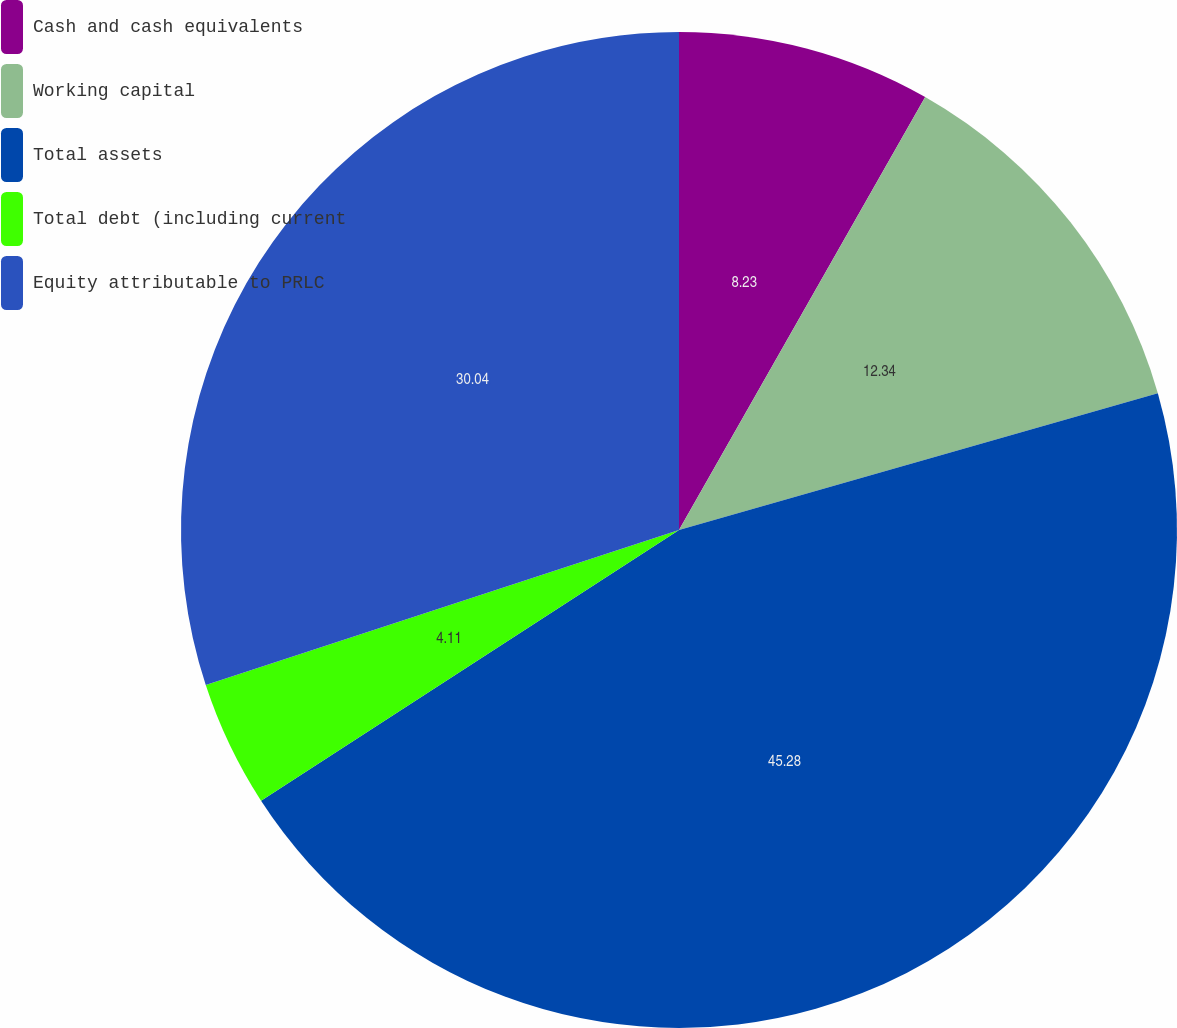<chart> <loc_0><loc_0><loc_500><loc_500><pie_chart><fcel>Cash and cash equivalents<fcel>Working capital<fcel>Total assets<fcel>Total debt (including current<fcel>Equity attributable to PRLC<nl><fcel>8.23%<fcel>12.34%<fcel>45.28%<fcel>4.11%<fcel>30.04%<nl></chart> 